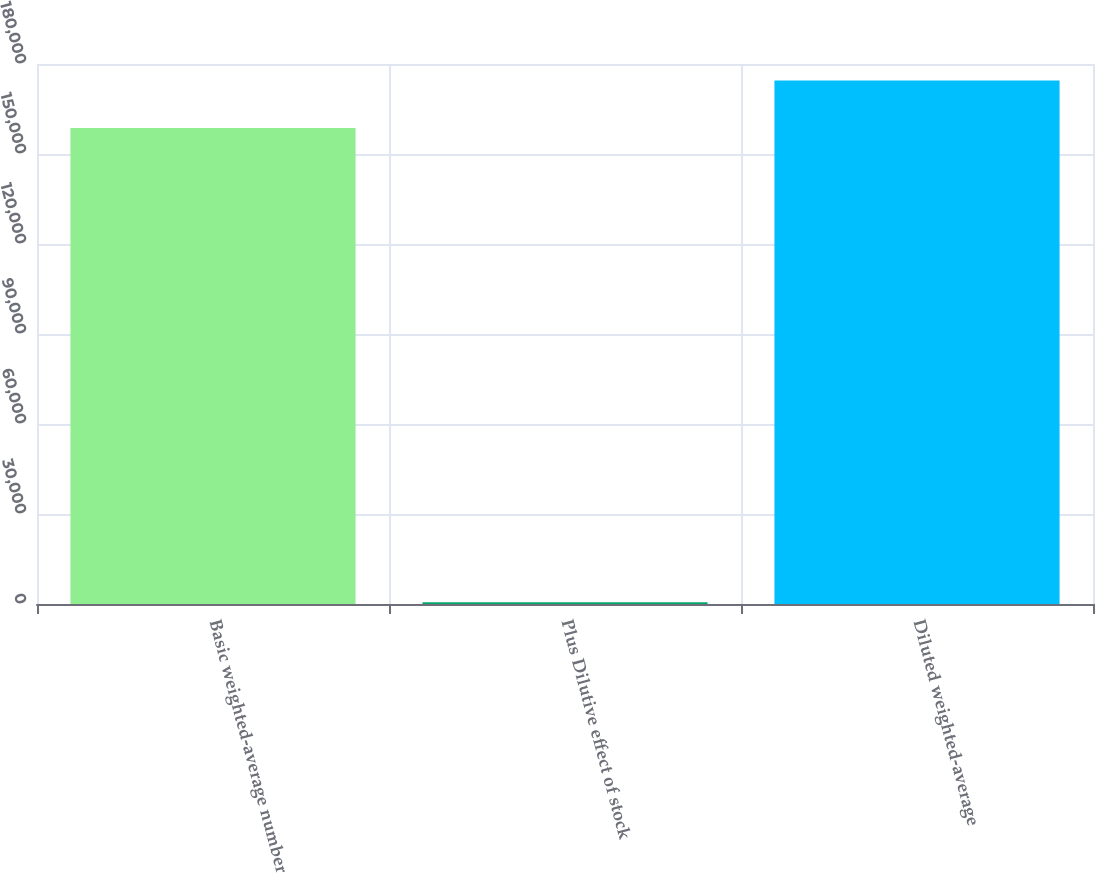Convert chart to OTSL. <chart><loc_0><loc_0><loc_500><loc_500><bar_chart><fcel>Basic weighted-average number<fcel>Plus Dilutive effect of stock<fcel>Diluted weighted-average<nl><fcel>158672<fcel>599<fcel>174539<nl></chart> 